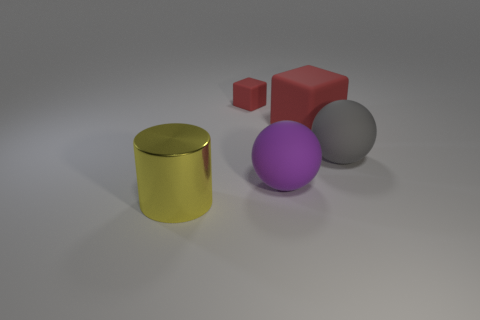Subtract all cylinders. How many objects are left? 4 Add 1 cubes. How many objects exist? 6 Subtract all purple balls. How many balls are left? 1 Subtract 1 spheres. How many spheres are left? 1 Subtract all brown balls. Subtract all purple cylinders. How many balls are left? 2 Subtract all green cylinders. How many gray balls are left? 1 Subtract all small blue matte things. Subtract all large matte things. How many objects are left? 2 Add 3 blocks. How many blocks are left? 5 Add 3 brown objects. How many brown objects exist? 3 Subtract 0 red balls. How many objects are left? 5 